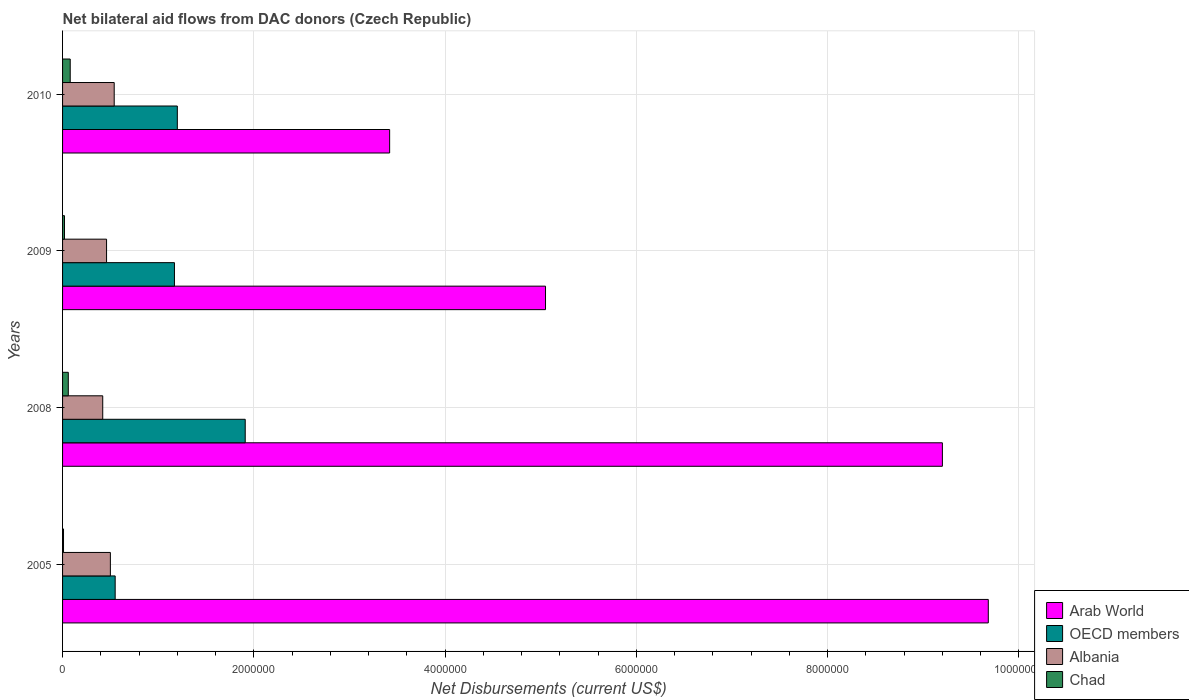How many different coloured bars are there?
Provide a short and direct response. 4. Are the number of bars on each tick of the Y-axis equal?
Provide a succinct answer. Yes. What is the label of the 3rd group of bars from the top?
Your answer should be compact. 2008. In how many cases, is the number of bars for a given year not equal to the number of legend labels?
Your answer should be compact. 0. What is the net bilateral aid flows in Arab World in 2010?
Provide a succinct answer. 3.42e+06. Across all years, what is the minimum net bilateral aid flows in Chad?
Provide a short and direct response. 10000. In which year was the net bilateral aid flows in Arab World maximum?
Your answer should be very brief. 2005. In which year was the net bilateral aid flows in Arab World minimum?
Offer a very short reply. 2010. What is the total net bilateral aid flows in Albania in the graph?
Give a very brief answer. 1.92e+06. What is the difference between the net bilateral aid flows in OECD members in 2009 and that in 2010?
Keep it short and to the point. -3.00e+04. What is the difference between the net bilateral aid flows in OECD members in 2010 and the net bilateral aid flows in Albania in 2009?
Make the answer very short. 7.40e+05. What is the average net bilateral aid flows in Albania per year?
Provide a succinct answer. 4.80e+05. What is the ratio of the net bilateral aid flows in OECD members in 2005 to that in 2008?
Provide a short and direct response. 0.29. What is the difference between the highest and the second highest net bilateral aid flows in OECD members?
Offer a very short reply. 7.10e+05. What is the difference between the highest and the lowest net bilateral aid flows in Albania?
Offer a terse response. 1.20e+05. In how many years, is the net bilateral aid flows in OECD members greater than the average net bilateral aid flows in OECD members taken over all years?
Your answer should be very brief. 1. Is the sum of the net bilateral aid flows in Chad in 2005 and 2009 greater than the maximum net bilateral aid flows in OECD members across all years?
Offer a terse response. No. What does the 1st bar from the bottom in 2009 represents?
Offer a terse response. Arab World. How many bars are there?
Your answer should be compact. 16. What is the difference between two consecutive major ticks on the X-axis?
Ensure brevity in your answer.  2.00e+06. Are the values on the major ticks of X-axis written in scientific E-notation?
Provide a succinct answer. No. Does the graph contain any zero values?
Keep it short and to the point. No. How many legend labels are there?
Keep it short and to the point. 4. What is the title of the graph?
Your response must be concise. Net bilateral aid flows from DAC donors (Czech Republic). What is the label or title of the X-axis?
Your answer should be compact. Net Disbursements (current US$). What is the label or title of the Y-axis?
Keep it short and to the point. Years. What is the Net Disbursements (current US$) in Arab World in 2005?
Keep it short and to the point. 9.68e+06. What is the Net Disbursements (current US$) in OECD members in 2005?
Your answer should be very brief. 5.50e+05. What is the Net Disbursements (current US$) of Chad in 2005?
Make the answer very short. 10000. What is the Net Disbursements (current US$) in Arab World in 2008?
Your answer should be compact. 9.20e+06. What is the Net Disbursements (current US$) in OECD members in 2008?
Your answer should be compact. 1.91e+06. What is the Net Disbursements (current US$) of Chad in 2008?
Offer a terse response. 6.00e+04. What is the Net Disbursements (current US$) in Arab World in 2009?
Make the answer very short. 5.05e+06. What is the Net Disbursements (current US$) in OECD members in 2009?
Provide a succinct answer. 1.17e+06. What is the Net Disbursements (current US$) of Arab World in 2010?
Offer a very short reply. 3.42e+06. What is the Net Disbursements (current US$) in OECD members in 2010?
Give a very brief answer. 1.20e+06. What is the Net Disbursements (current US$) of Albania in 2010?
Your response must be concise. 5.40e+05. Across all years, what is the maximum Net Disbursements (current US$) in Arab World?
Offer a terse response. 9.68e+06. Across all years, what is the maximum Net Disbursements (current US$) of OECD members?
Provide a short and direct response. 1.91e+06. Across all years, what is the maximum Net Disbursements (current US$) in Albania?
Provide a short and direct response. 5.40e+05. Across all years, what is the maximum Net Disbursements (current US$) of Chad?
Provide a short and direct response. 8.00e+04. Across all years, what is the minimum Net Disbursements (current US$) of Arab World?
Keep it short and to the point. 3.42e+06. Across all years, what is the minimum Net Disbursements (current US$) of Chad?
Make the answer very short. 10000. What is the total Net Disbursements (current US$) in Arab World in the graph?
Provide a succinct answer. 2.74e+07. What is the total Net Disbursements (current US$) in OECD members in the graph?
Offer a very short reply. 4.83e+06. What is the total Net Disbursements (current US$) of Albania in the graph?
Offer a very short reply. 1.92e+06. What is the difference between the Net Disbursements (current US$) in Arab World in 2005 and that in 2008?
Provide a short and direct response. 4.80e+05. What is the difference between the Net Disbursements (current US$) of OECD members in 2005 and that in 2008?
Your answer should be very brief. -1.36e+06. What is the difference between the Net Disbursements (current US$) in Albania in 2005 and that in 2008?
Provide a short and direct response. 8.00e+04. What is the difference between the Net Disbursements (current US$) of Chad in 2005 and that in 2008?
Offer a terse response. -5.00e+04. What is the difference between the Net Disbursements (current US$) of Arab World in 2005 and that in 2009?
Offer a terse response. 4.63e+06. What is the difference between the Net Disbursements (current US$) in OECD members in 2005 and that in 2009?
Make the answer very short. -6.20e+05. What is the difference between the Net Disbursements (current US$) of Chad in 2005 and that in 2009?
Provide a short and direct response. -10000. What is the difference between the Net Disbursements (current US$) in Arab World in 2005 and that in 2010?
Offer a terse response. 6.26e+06. What is the difference between the Net Disbursements (current US$) in OECD members in 2005 and that in 2010?
Provide a short and direct response. -6.50e+05. What is the difference between the Net Disbursements (current US$) of Arab World in 2008 and that in 2009?
Your answer should be very brief. 4.15e+06. What is the difference between the Net Disbursements (current US$) in OECD members in 2008 and that in 2009?
Ensure brevity in your answer.  7.40e+05. What is the difference between the Net Disbursements (current US$) in Chad in 2008 and that in 2009?
Provide a succinct answer. 4.00e+04. What is the difference between the Net Disbursements (current US$) in Arab World in 2008 and that in 2010?
Your response must be concise. 5.78e+06. What is the difference between the Net Disbursements (current US$) of OECD members in 2008 and that in 2010?
Keep it short and to the point. 7.10e+05. What is the difference between the Net Disbursements (current US$) in Albania in 2008 and that in 2010?
Offer a terse response. -1.20e+05. What is the difference between the Net Disbursements (current US$) of Arab World in 2009 and that in 2010?
Make the answer very short. 1.63e+06. What is the difference between the Net Disbursements (current US$) in Chad in 2009 and that in 2010?
Offer a terse response. -6.00e+04. What is the difference between the Net Disbursements (current US$) of Arab World in 2005 and the Net Disbursements (current US$) of OECD members in 2008?
Keep it short and to the point. 7.77e+06. What is the difference between the Net Disbursements (current US$) in Arab World in 2005 and the Net Disbursements (current US$) in Albania in 2008?
Offer a terse response. 9.26e+06. What is the difference between the Net Disbursements (current US$) of Arab World in 2005 and the Net Disbursements (current US$) of Chad in 2008?
Give a very brief answer. 9.62e+06. What is the difference between the Net Disbursements (current US$) of OECD members in 2005 and the Net Disbursements (current US$) of Albania in 2008?
Your answer should be very brief. 1.30e+05. What is the difference between the Net Disbursements (current US$) of Albania in 2005 and the Net Disbursements (current US$) of Chad in 2008?
Your answer should be compact. 4.40e+05. What is the difference between the Net Disbursements (current US$) in Arab World in 2005 and the Net Disbursements (current US$) in OECD members in 2009?
Keep it short and to the point. 8.51e+06. What is the difference between the Net Disbursements (current US$) in Arab World in 2005 and the Net Disbursements (current US$) in Albania in 2009?
Give a very brief answer. 9.22e+06. What is the difference between the Net Disbursements (current US$) in Arab World in 2005 and the Net Disbursements (current US$) in Chad in 2009?
Your answer should be very brief. 9.66e+06. What is the difference between the Net Disbursements (current US$) in OECD members in 2005 and the Net Disbursements (current US$) in Chad in 2009?
Ensure brevity in your answer.  5.30e+05. What is the difference between the Net Disbursements (current US$) in Albania in 2005 and the Net Disbursements (current US$) in Chad in 2009?
Ensure brevity in your answer.  4.80e+05. What is the difference between the Net Disbursements (current US$) of Arab World in 2005 and the Net Disbursements (current US$) of OECD members in 2010?
Your answer should be compact. 8.48e+06. What is the difference between the Net Disbursements (current US$) in Arab World in 2005 and the Net Disbursements (current US$) in Albania in 2010?
Your response must be concise. 9.14e+06. What is the difference between the Net Disbursements (current US$) in Arab World in 2005 and the Net Disbursements (current US$) in Chad in 2010?
Make the answer very short. 9.60e+06. What is the difference between the Net Disbursements (current US$) of Arab World in 2008 and the Net Disbursements (current US$) of OECD members in 2009?
Provide a succinct answer. 8.03e+06. What is the difference between the Net Disbursements (current US$) in Arab World in 2008 and the Net Disbursements (current US$) in Albania in 2009?
Make the answer very short. 8.74e+06. What is the difference between the Net Disbursements (current US$) of Arab World in 2008 and the Net Disbursements (current US$) of Chad in 2009?
Provide a short and direct response. 9.18e+06. What is the difference between the Net Disbursements (current US$) in OECD members in 2008 and the Net Disbursements (current US$) in Albania in 2009?
Offer a terse response. 1.45e+06. What is the difference between the Net Disbursements (current US$) in OECD members in 2008 and the Net Disbursements (current US$) in Chad in 2009?
Make the answer very short. 1.89e+06. What is the difference between the Net Disbursements (current US$) in Arab World in 2008 and the Net Disbursements (current US$) in OECD members in 2010?
Ensure brevity in your answer.  8.00e+06. What is the difference between the Net Disbursements (current US$) of Arab World in 2008 and the Net Disbursements (current US$) of Albania in 2010?
Your response must be concise. 8.66e+06. What is the difference between the Net Disbursements (current US$) in Arab World in 2008 and the Net Disbursements (current US$) in Chad in 2010?
Ensure brevity in your answer.  9.12e+06. What is the difference between the Net Disbursements (current US$) of OECD members in 2008 and the Net Disbursements (current US$) of Albania in 2010?
Ensure brevity in your answer.  1.37e+06. What is the difference between the Net Disbursements (current US$) in OECD members in 2008 and the Net Disbursements (current US$) in Chad in 2010?
Provide a succinct answer. 1.83e+06. What is the difference between the Net Disbursements (current US$) in Arab World in 2009 and the Net Disbursements (current US$) in OECD members in 2010?
Your response must be concise. 3.85e+06. What is the difference between the Net Disbursements (current US$) in Arab World in 2009 and the Net Disbursements (current US$) in Albania in 2010?
Provide a succinct answer. 4.51e+06. What is the difference between the Net Disbursements (current US$) in Arab World in 2009 and the Net Disbursements (current US$) in Chad in 2010?
Your answer should be very brief. 4.97e+06. What is the difference between the Net Disbursements (current US$) of OECD members in 2009 and the Net Disbursements (current US$) of Albania in 2010?
Keep it short and to the point. 6.30e+05. What is the difference between the Net Disbursements (current US$) of OECD members in 2009 and the Net Disbursements (current US$) of Chad in 2010?
Provide a succinct answer. 1.09e+06. What is the average Net Disbursements (current US$) in Arab World per year?
Provide a short and direct response. 6.84e+06. What is the average Net Disbursements (current US$) of OECD members per year?
Provide a short and direct response. 1.21e+06. What is the average Net Disbursements (current US$) in Chad per year?
Give a very brief answer. 4.25e+04. In the year 2005, what is the difference between the Net Disbursements (current US$) in Arab World and Net Disbursements (current US$) in OECD members?
Your answer should be very brief. 9.13e+06. In the year 2005, what is the difference between the Net Disbursements (current US$) of Arab World and Net Disbursements (current US$) of Albania?
Provide a short and direct response. 9.18e+06. In the year 2005, what is the difference between the Net Disbursements (current US$) of Arab World and Net Disbursements (current US$) of Chad?
Keep it short and to the point. 9.67e+06. In the year 2005, what is the difference between the Net Disbursements (current US$) in OECD members and Net Disbursements (current US$) in Albania?
Your answer should be very brief. 5.00e+04. In the year 2005, what is the difference between the Net Disbursements (current US$) of OECD members and Net Disbursements (current US$) of Chad?
Give a very brief answer. 5.40e+05. In the year 2008, what is the difference between the Net Disbursements (current US$) in Arab World and Net Disbursements (current US$) in OECD members?
Your answer should be very brief. 7.29e+06. In the year 2008, what is the difference between the Net Disbursements (current US$) of Arab World and Net Disbursements (current US$) of Albania?
Provide a succinct answer. 8.78e+06. In the year 2008, what is the difference between the Net Disbursements (current US$) in Arab World and Net Disbursements (current US$) in Chad?
Offer a very short reply. 9.14e+06. In the year 2008, what is the difference between the Net Disbursements (current US$) in OECD members and Net Disbursements (current US$) in Albania?
Your answer should be compact. 1.49e+06. In the year 2008, what is the difference between the Net Disbursements (current US$) in OECD members and Net Disbursements (current US$) in Chad?
Offer a very short reply. 1.85e+06. In the year 2008, what is the difference between the Net Disbursements (current US$) in Albania and Net Disbursements (current US$) in Chad?
Offer a very short reply. 3.60e+05. In the year 2009, what is the difference between the Net Disbursements (current US$) of Arab World and Net Disbursements (current US$) of OECD members?
Your answer should be very brief. 3.88e+06. In the year 2009, what is the difference between the Net Disbursements (current US$) of Arab World and Net Disbursements (current US$) of Albania?
Offer a very short reply. 4.59e+06. In the year 2009, what is the difference between the Net Disbursements (current US$) in Arab World and Net Disbursements (current US$) in Chad?
Your answer should be very brief. 5.03e+06. In the year 2009, what is the difference between the Net Disbursements (current US$) in OECD members and Net Disbursements (current US$) in Albania?
Provide a short and direct response. 7.10e+05. In the year 2009, what is the difference between the Net Disbursements (current US$) in OECD members and Net Disbursements (current US$) in Chad?
Offer a terse response. 1.15e+06. In the year 2009, what is the difference between the Net Disbursements (current US$) of Albania and Net Disbursements (current US$) of Chad?
Your answer should be very brief. 4.40e+05. In the year 2010, what is the difference between the Net Disbursements (current US$) in Arab World and Net Disbursements (current US$) in OECD members?
Give a very brief answer. 2.22e+06. In the year 2010, what is the difference between the Net Disbursements (current US$) of Arab World and Net Disbursements (current US$) of Albania?
Offer a terse response. 2.88e+06. In the year 2010, what is the difference between the Net Disbursements (current US$) in Arab World and Net Disbursements (current US$) in Chad?
Provide a succinct answer. 3.34e+06. In the year 2010, what is the difference between the Net Disbursements (current US$) in OECD members and Net Disbursements (current US$) in Albania?
Provide a succinct answer. 6.60e+05. In the year 2010, what is the difference between the Net Disbursements (current US$) of OECD members and Net Disbursements (current US$) of Chad?
Provide a succinct answer. 1.12e+06. What is the ratio of the Net Disbursements (current US$) of Arab World in 2005 to that in 2008?
Make the answer very short. 1.05. What is the ratio of the Net Disbursements (current US$) of OECD members in 2005 to that in 2008?
Your answer should be compact. 0.29. What is the ratio of the Net Disbursements (current US$) of Albania in 2005 to that in 2008?
Your response must be concise. 1.19. What is the ratio of the Net Disbursements (current US$) in Chad in 2005 to that in 2008?
Provide a succinct answer. 0.17. What is the ratio of the Net Disbursements (current US$) of Arab World in 2005 to that in 2009?
Provide a short and direct response. 1.92. What is the ratio of the Net Disbursements (current US$) of OECD members in 2005 to that in 2009?
Offer a very short reply. 0.47. What is the ratio of the Net Disbursements (current US$) of Albania in 2005 to that in 2009?
Make the answer very short. 1.09. What is the ratio of the Net Disbursements (current US$) in Arab World in 2005 to that in 2010?
Your answer should be very brief. 2.83. What is the ratio of the Net Disbursements (current US$) in OECD members in 2005 to that in 2010?
Give a very brief answer. 0.46. What is the ratio of the Net Disbursements (current US$) in Albania in 2005 to that in 2010?
Ensure brevity in your answer.  0.93. What is the ratio of the Net Disbursements (current US$) of Chad in 2005 to that in 2010?
Provide a short and direct response. 0.12. What is the ratio of the Net Disbursements (current US$) in Arab World in 2008 to that in 2009?
Provide a short and direct response. 1.82. What is the ratio of the Net Disbursements (current US$) in OECD members in 2008 to that in 2009?
Ensure brevity in your answer.  1.63. What is the ratio of the Net Disbursements (current US$) in Chad in 2008 to that in 2009?
Offer a very short reply. 3. What is the ratio of the Net Disbursements (current US$) in Arab World in 2008 to that in 2010?
Give a very brief answer. 2.69. What is the ratio of the Net Disbursements (current US$) of OECD members in 2008 to that in 2010?
Make the answer very short. 1.59. What is the ratio of the Net Disbursements (current US$) in Arab World in 2009 to that in 2010?
Keep it short and to the point. 1.48. What is the ratio of the Net Disbursements (current US$) in OECD members in 2009 to that in 2010?
Keep it short and to the point. 0.97. What is the ratio of the Net Disbursements (current US$) of Albania in 2009 to that in 2010?
Give a very brief answer. 0.85. What is the difference between the highest and the second highest Net Disbursements (current US$) of Arab World?
Provide a succinct answer. 4.80e+05. What is the difference between the highest and the second highest Net Disbursements (current US$) of OECD members?
Provide a succinct answer. 7.10e+05. What is the difference between the highest and the second highest Net Disbursements (current US$) of Albania?
Your answer should be very brief. 4.00e+04. What is the difference between the highest and the lowest Net Disbursements (current US$) in Arab World?
Provide a short and direct response. 6.26e+06. What is the difference between the highest and the lowest Net Disbursements (current US$) of OECD members?
Provide a short and direct response. 1.36e+06. What is the difference between the highest and the lowest Net Disbursements (current US$) in Albania?
Offer a very short reply. 1.20e+05. What is the difference between the highest and the lowest Net Disbursements (current US$) in Chad?
Keep it short and to the point. 7.00e+04. 